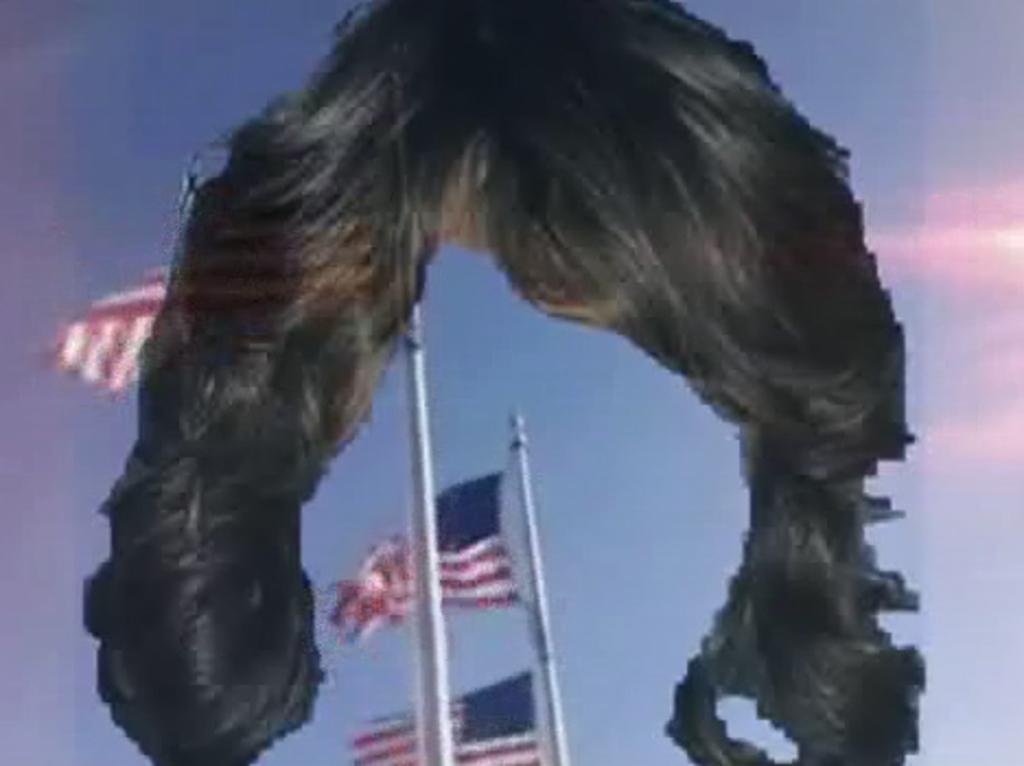How would you summarize this image in a sentence or two? This is an edited picture. In this picture we can see a wig, poles, flags and in the background we can see the sky. 